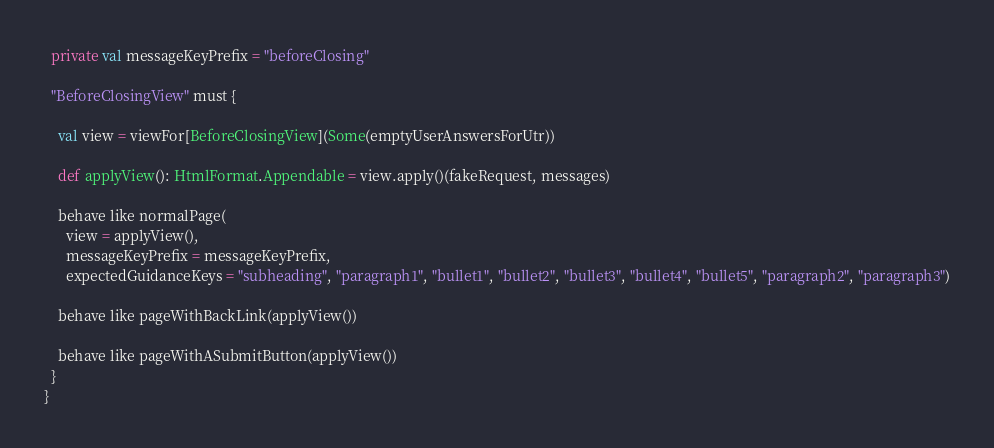<code> <loc_0><loc_0><loc_500><loc_500><_Scala_>
  private val messageKeyPrefix = "beforeClosing"

  "BeforeClosingView" must {

    val view = viewFor[BeforeClosingView](Some(emptyUserAnswersForUtr))

    def applyView(): HtmlFormat.Appendable = view.apply()(fakeRequest, messages)

    behave like normalPage(
      view = applyView(),
      messageKeyPrefix = messageKeyPrefix,
      expectedGuidanceKeys = "subheading", "paragraph1", "bullet1", "bullet2", "bullet3", "bullet4", "bullet5", "paragraph2", "paragraph3")

    behave like pageWithBackLink(applyView())

    behave like pageWithASubmitButton(applyView())
  }
}
</code> 